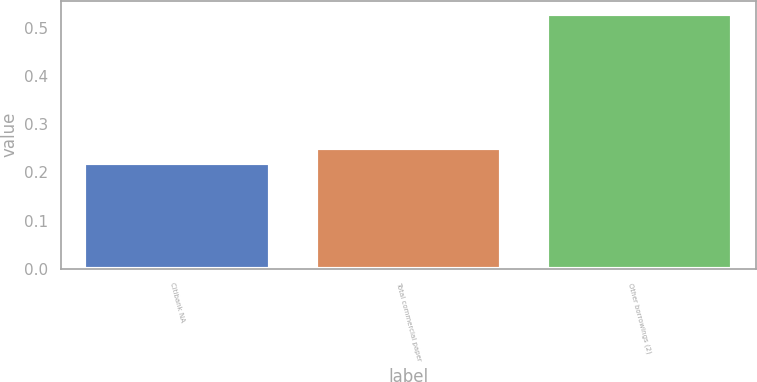Convert chart. <chart><loc_0><loc_0><loc_500><loc_500><bar_chart><fcel>Citibank NA<fcel>Total commercial paper<fcel>Other borrowings (2)<nl><fcel>0.22<fcel>0.25<fcel>0.53<nl></chart> 